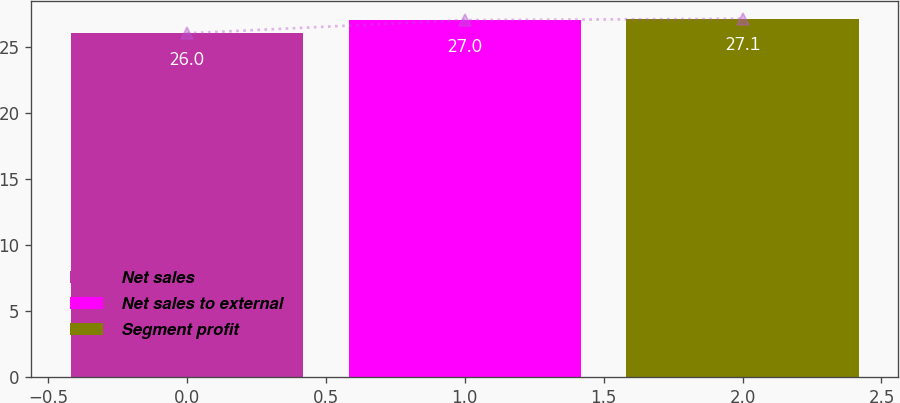Convert chart to OTSL. <chart><loc_0><loc_0><loc_500><loc_500><bar_chart><fcel>Net sales<fcel>Net sales to external<fcel>Segment profit<nl><fcel>26<fcel>27<fcel>27.1<nl></chart> 